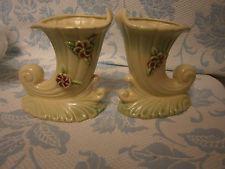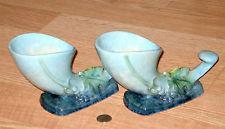The first image is the image on the left, the second image is the image on the right. For the images displayed, is the sentence "Each image contains a pair of matching objects." factually correct? Answer yes or no. Yes. The first image is the image on the left, the second image is the image on the right. For the images shown, is this caption "Each image contains at least two vases shaped like ocean waves, and the left image shows the waves facing each other, while the right image shows them aimed leftward." true? Answer yes or no. Yes. 